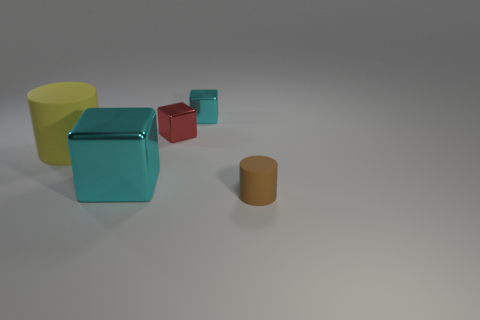The thing that is to the left of the red metallic object and to the right of the large cylinder has what shape?
Provide a succinct answer. Cube. How many small cyan shiny cylinders are there?
Your response must be concise. 0. There is another small cylinder that is made of the same material as the yellow cylinder; what is its color?
Provide a succinct answer. Brown. Is the number of brown matte things greater than the number of purple matte blocks?
Keep it short and to the point. Yes. There is a object that is behind the big cyan shiny cube and in front of the tiny red shiny thing; what size is it?
Your response must be concise. Large. Are there an equal number of big matte things that are right of the yellow thing and small red rubber blocks?
Offer a very short reply. Yes. Is the size of the brown object the same as the yellow matte cylinder?
Your answer should be compact. No. There is a thing that is both left of the small red metallic thing and to the right of the large matte cylinder; what color is it?
Your response must be concise. Cyan. What is the material of the cylinder that is left of the tiny shiny block in front of the small cyan thing?
Your answer should be compact. Rubber. There is another red shiny thing that is the same shape as the big shiny object; what size is it?
Your answer should be compact. Small. 